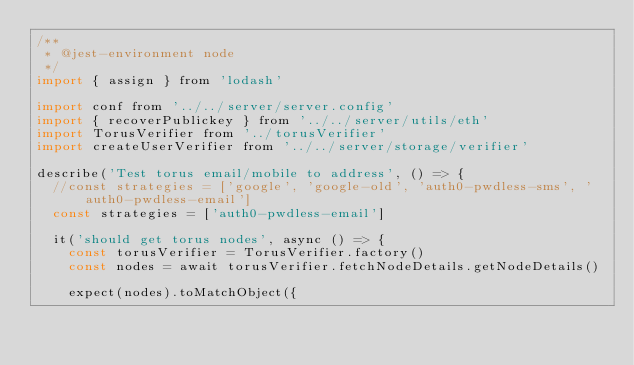<code> <loc_0><loc_0><loc_500><loc_500><_JavaScript_>/**
 * @jest-environment node
 */
import { assign } from 'lodash'

import conf from '../../server/server.config'
import { recoverPublickey } from '../../server/utils/eth'
import TorusVerifier from '../torusVerifier'
import createUserVerifier from '../../server/storage/verifier'

describe('Test torus email/mobile to address', () => {
  //const strategies = ['google', 'google-old', 'auth0-pwdless-sms', 'auth0-pwdless-email']
  const strategies = ['auth0-pwdless-email']

  it('should get torus nodes', async () => {
    const torusVerifier = TorusVerifier.factory()
    const nodes = await torusVerifier.fetchNodeDetails.getNodeDetails()

    expect(nodes).toMatchObject({</code> 